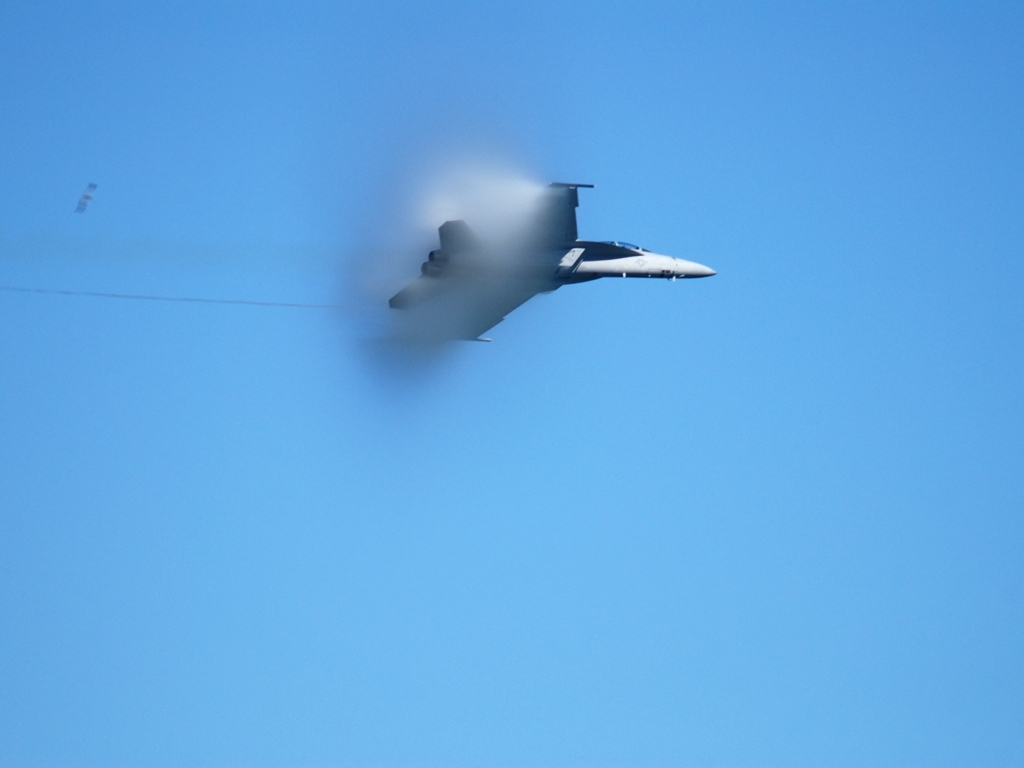Is the saturation level high?
A. Yes
B. No
Answer with the option's letter from the given choices directly.
 A. 